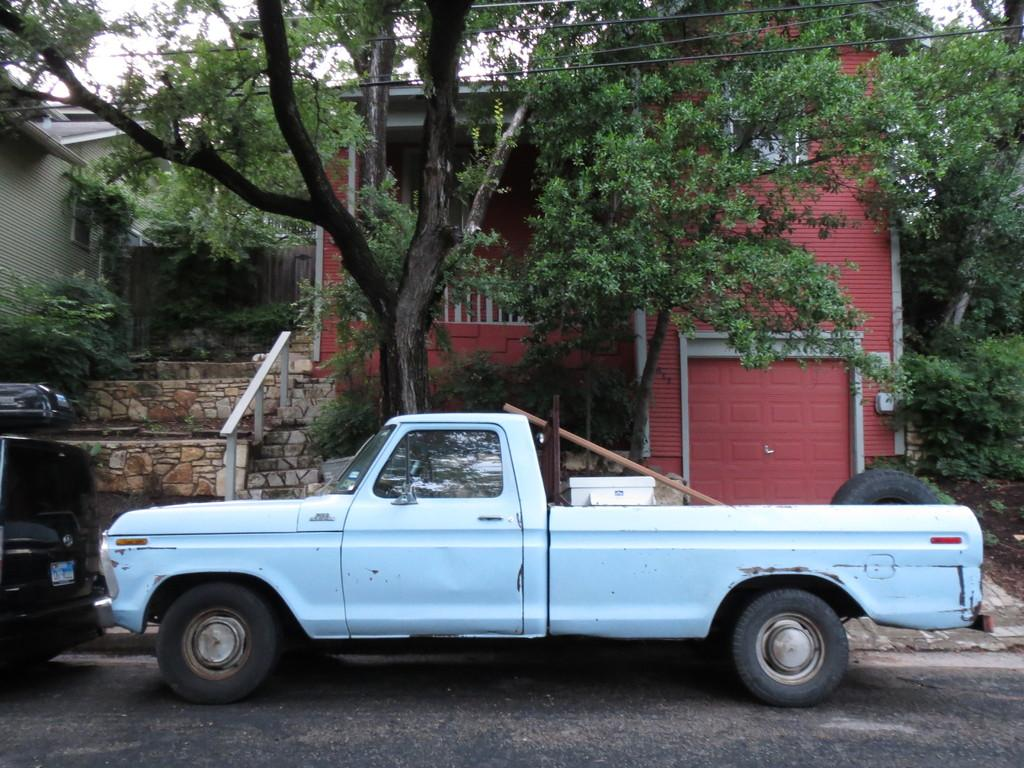What can be seen on the road in the image? There are vehicles on the road in the image. What is visible in the background of the image? There are trees, buildings, and cables in the background of the image. What type of vehicle is present in the image? There is a truck in the image. What is inside the truck? The truck contains a tyre and other things. How many doors can be seen on the truck in the image? There is no mention of doors on the truck in the image. What type of footwear is the truck wearing in the image? Trucks do not wear footwear; they are vehicles. 